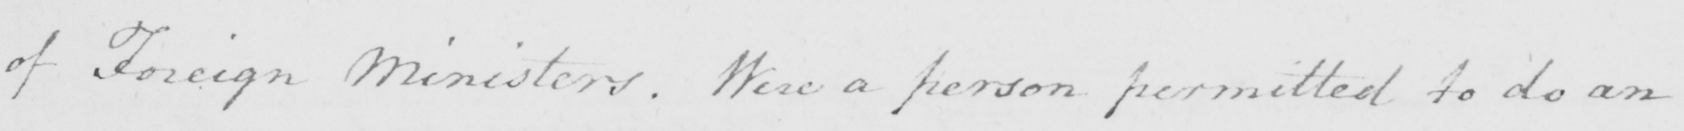Can you read and transcribe this handwriting? of Foreign Ministers . Were a person permitted to do an 